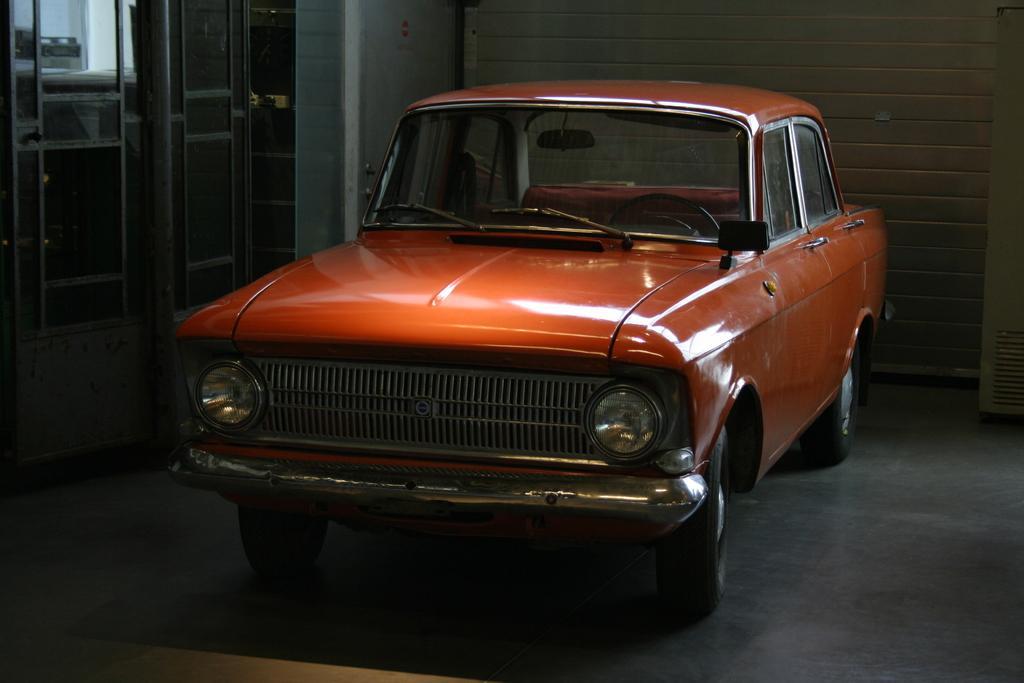How would you summarize this image in a sentence or two? In the front of the image there is a vehicle. In the background of the image there is a pole, wall and objects.   